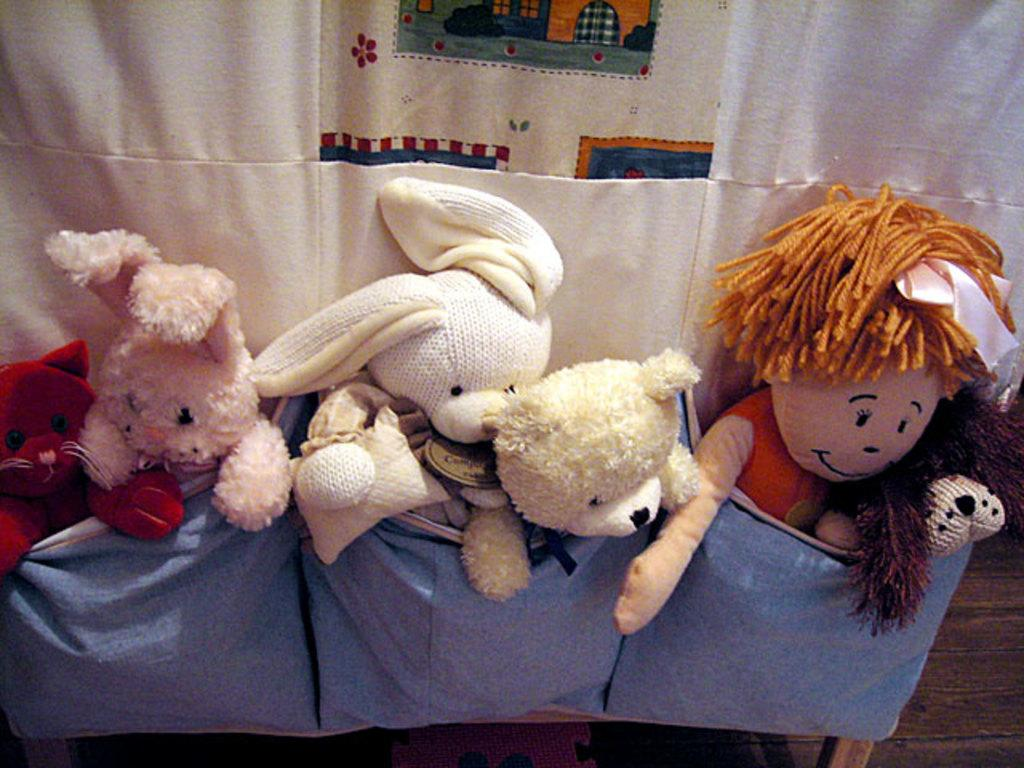What objects are present in the image? There are toys in the image. Where are the toys located? The toys are in the pockets of a white color cloth. What type of current can be seen flowing through the toys in the image? There is no current visible in the image, as it features toys in the pockets of a white color cloth. Can you see a pig interacting with the toys in the image? There is no pig present in the image; it only contains toys in the pockets of a white color cloth. 